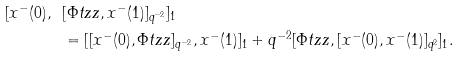<formula> <loc_0><loc_0><loc_500><loc_500>[ x ^ { - } ( 0 ) , \ & [ \Phi t z z , x ^ { - } ( 1 ) ] _ { q ^ { - 2 } } ] _ { 1 } \\ & = [ [ x ^ { - } ( 0 ) , \Phi t z z ] _ { q ^ { - 2 } } , x ^ { - } ( 1 ) ] _ { 1 } + q ^ { - 2 } [ \Phi t z z , [ x ^ { - } ( 0 ) , x ^ { - } ( 1 ) ] _ { q ^ { 2 } } ] _ { 1 } .</formula> 